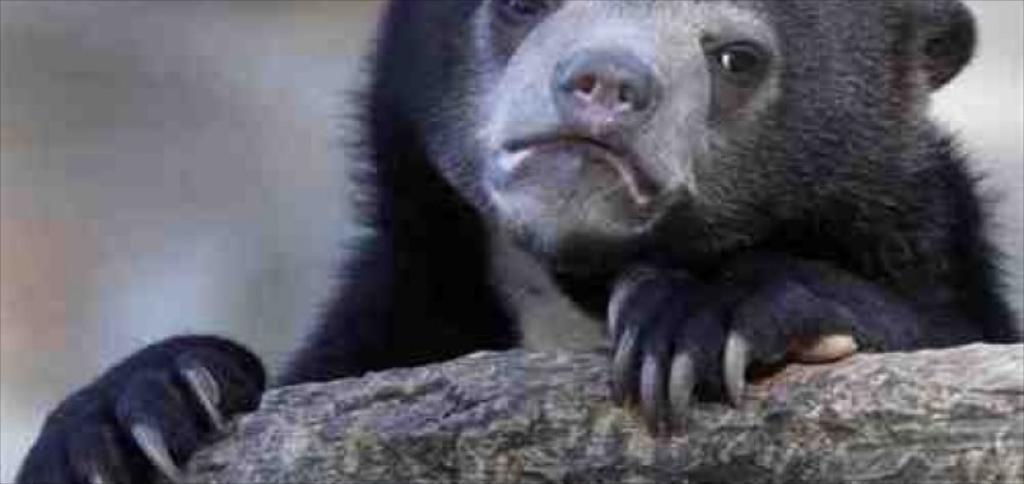What is the main subject of the image? There is an animal in the center of the image. What type of skirt is the animal wearing in the image? There is no skirt present in the image, as it features an animal and not a person. 